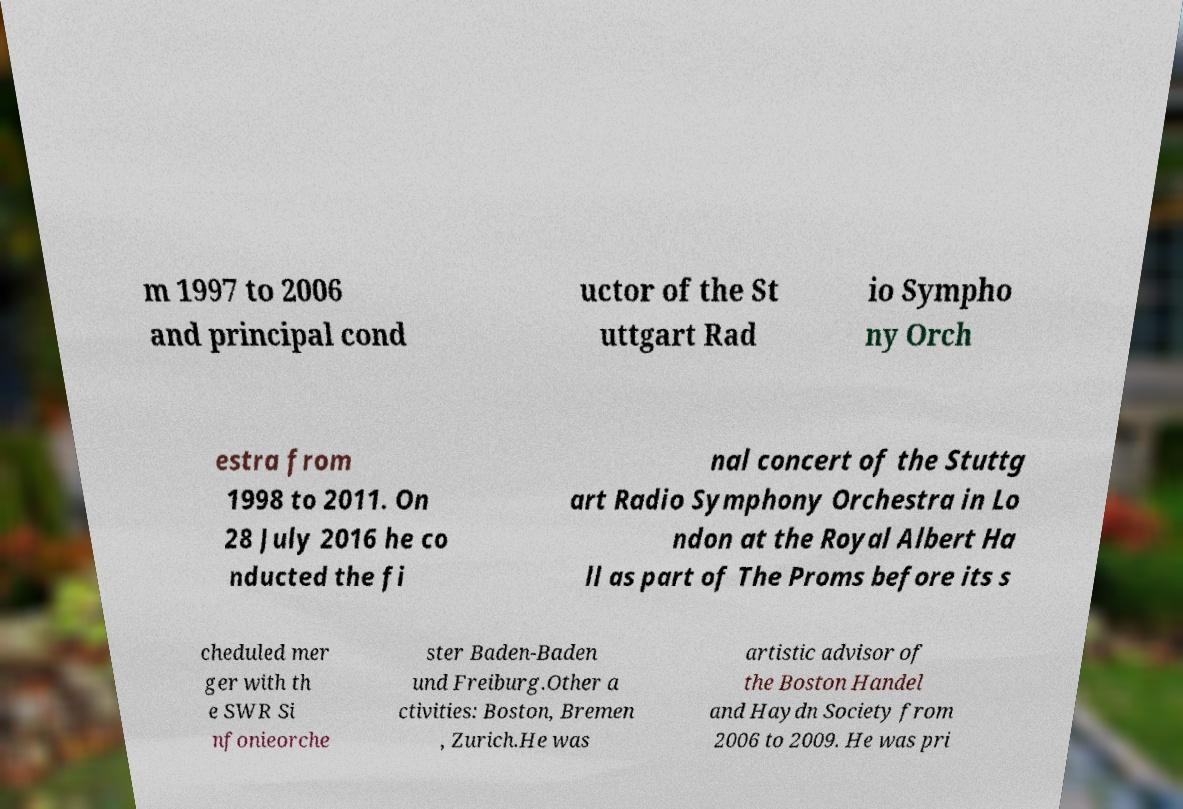There's text embedded in this image that I need extracted. Can you transcribe it verbatim? m 1997 to 2006 and principal cond uctor of the St uttgart Rad io Sympho ny Orch estra from 1998 to 2011. On 28 July 2016 he co nducted the fi nal concert of the Stuttg art Radio Symphony Orchestra in Lo ndon at the Royal Albert Ha ll as part of The Proms before its s cheduled mer ger with th e SWR Si nfonieorche ster Baden-Baden und Freiburg.Other a ctivities: Boston, Bremen , Zurich.He was artistic advisor of the Boston Handel and Haydn Society from 2006 to 2009. He was pri 